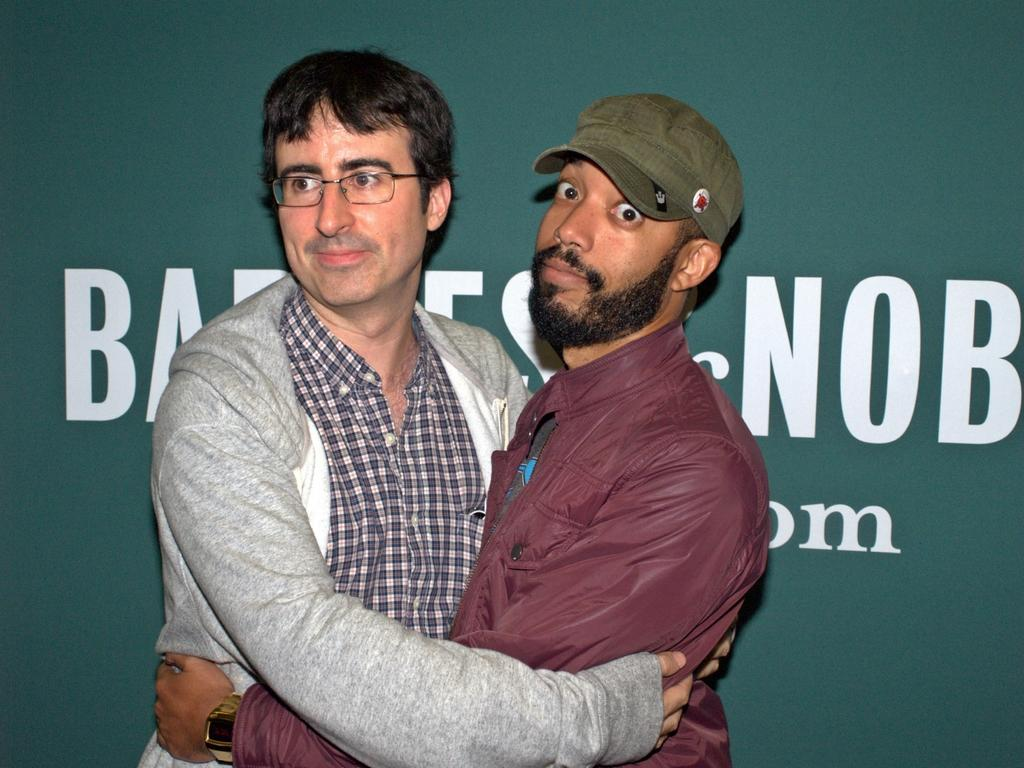How many people are in the image? There are two persons in the image. What are the two persons doing in the image? The two persons are standing and hugging. What can be seen in the background of the image? There is a banner visible in the background of the image. What type of pan can be seen on the ground in the image? There is no pan present in the image. How many children are visible in the image? The image only features two adults, and there are no children present. 